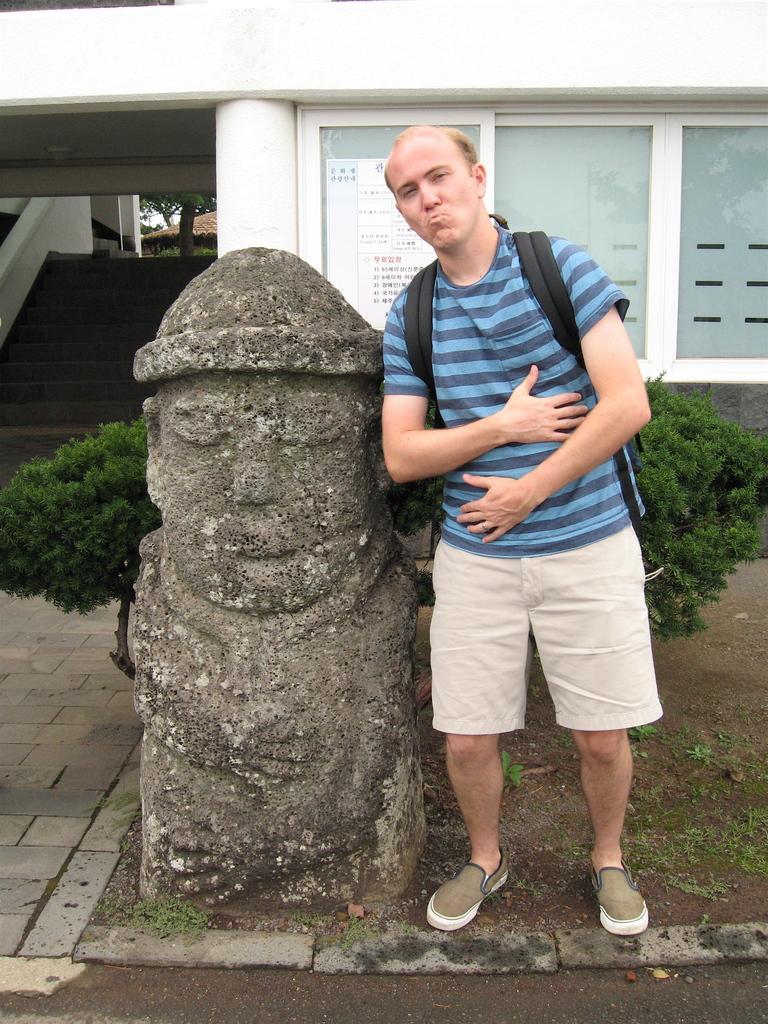Please provide a concise description of this image. In the center of the image we can see statue and person. In the background we can see trees, windows, stairs and building. 